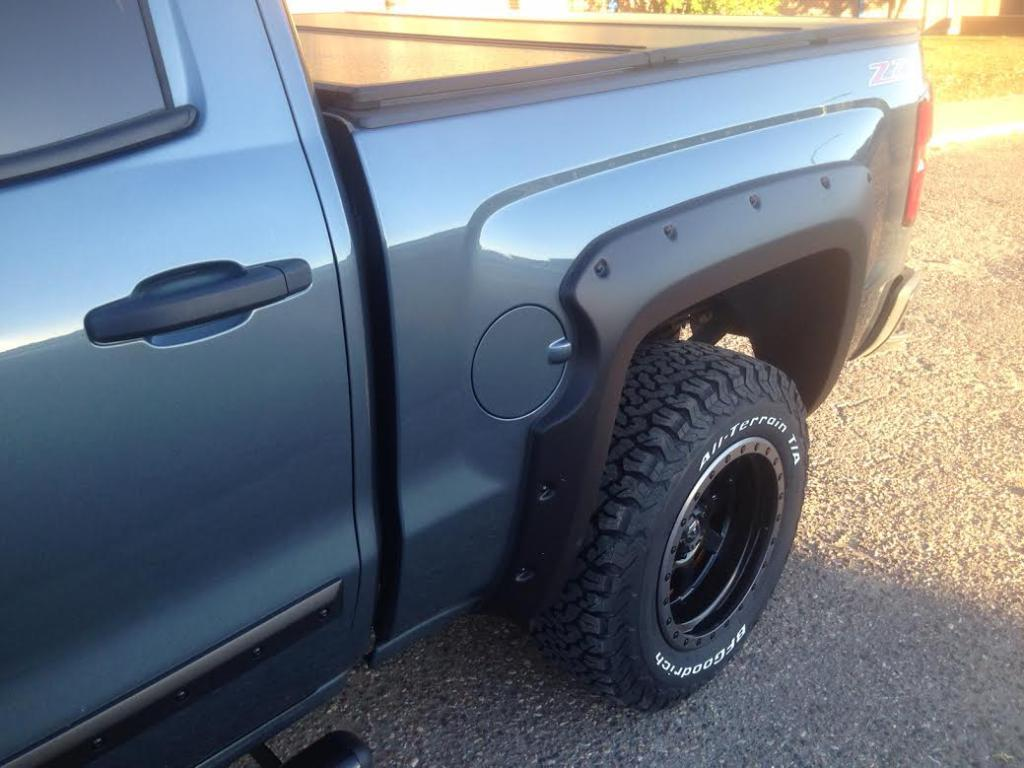What is the main subject in the image? There is a vehicle in the image. What can be seen in the background of the image? Trees are visible in the image. What type of verse can be heard recited by the vehicle in the image? There is no verse being recited by the vehicle in the image, as vehicles do not have the ability to recite verses. 